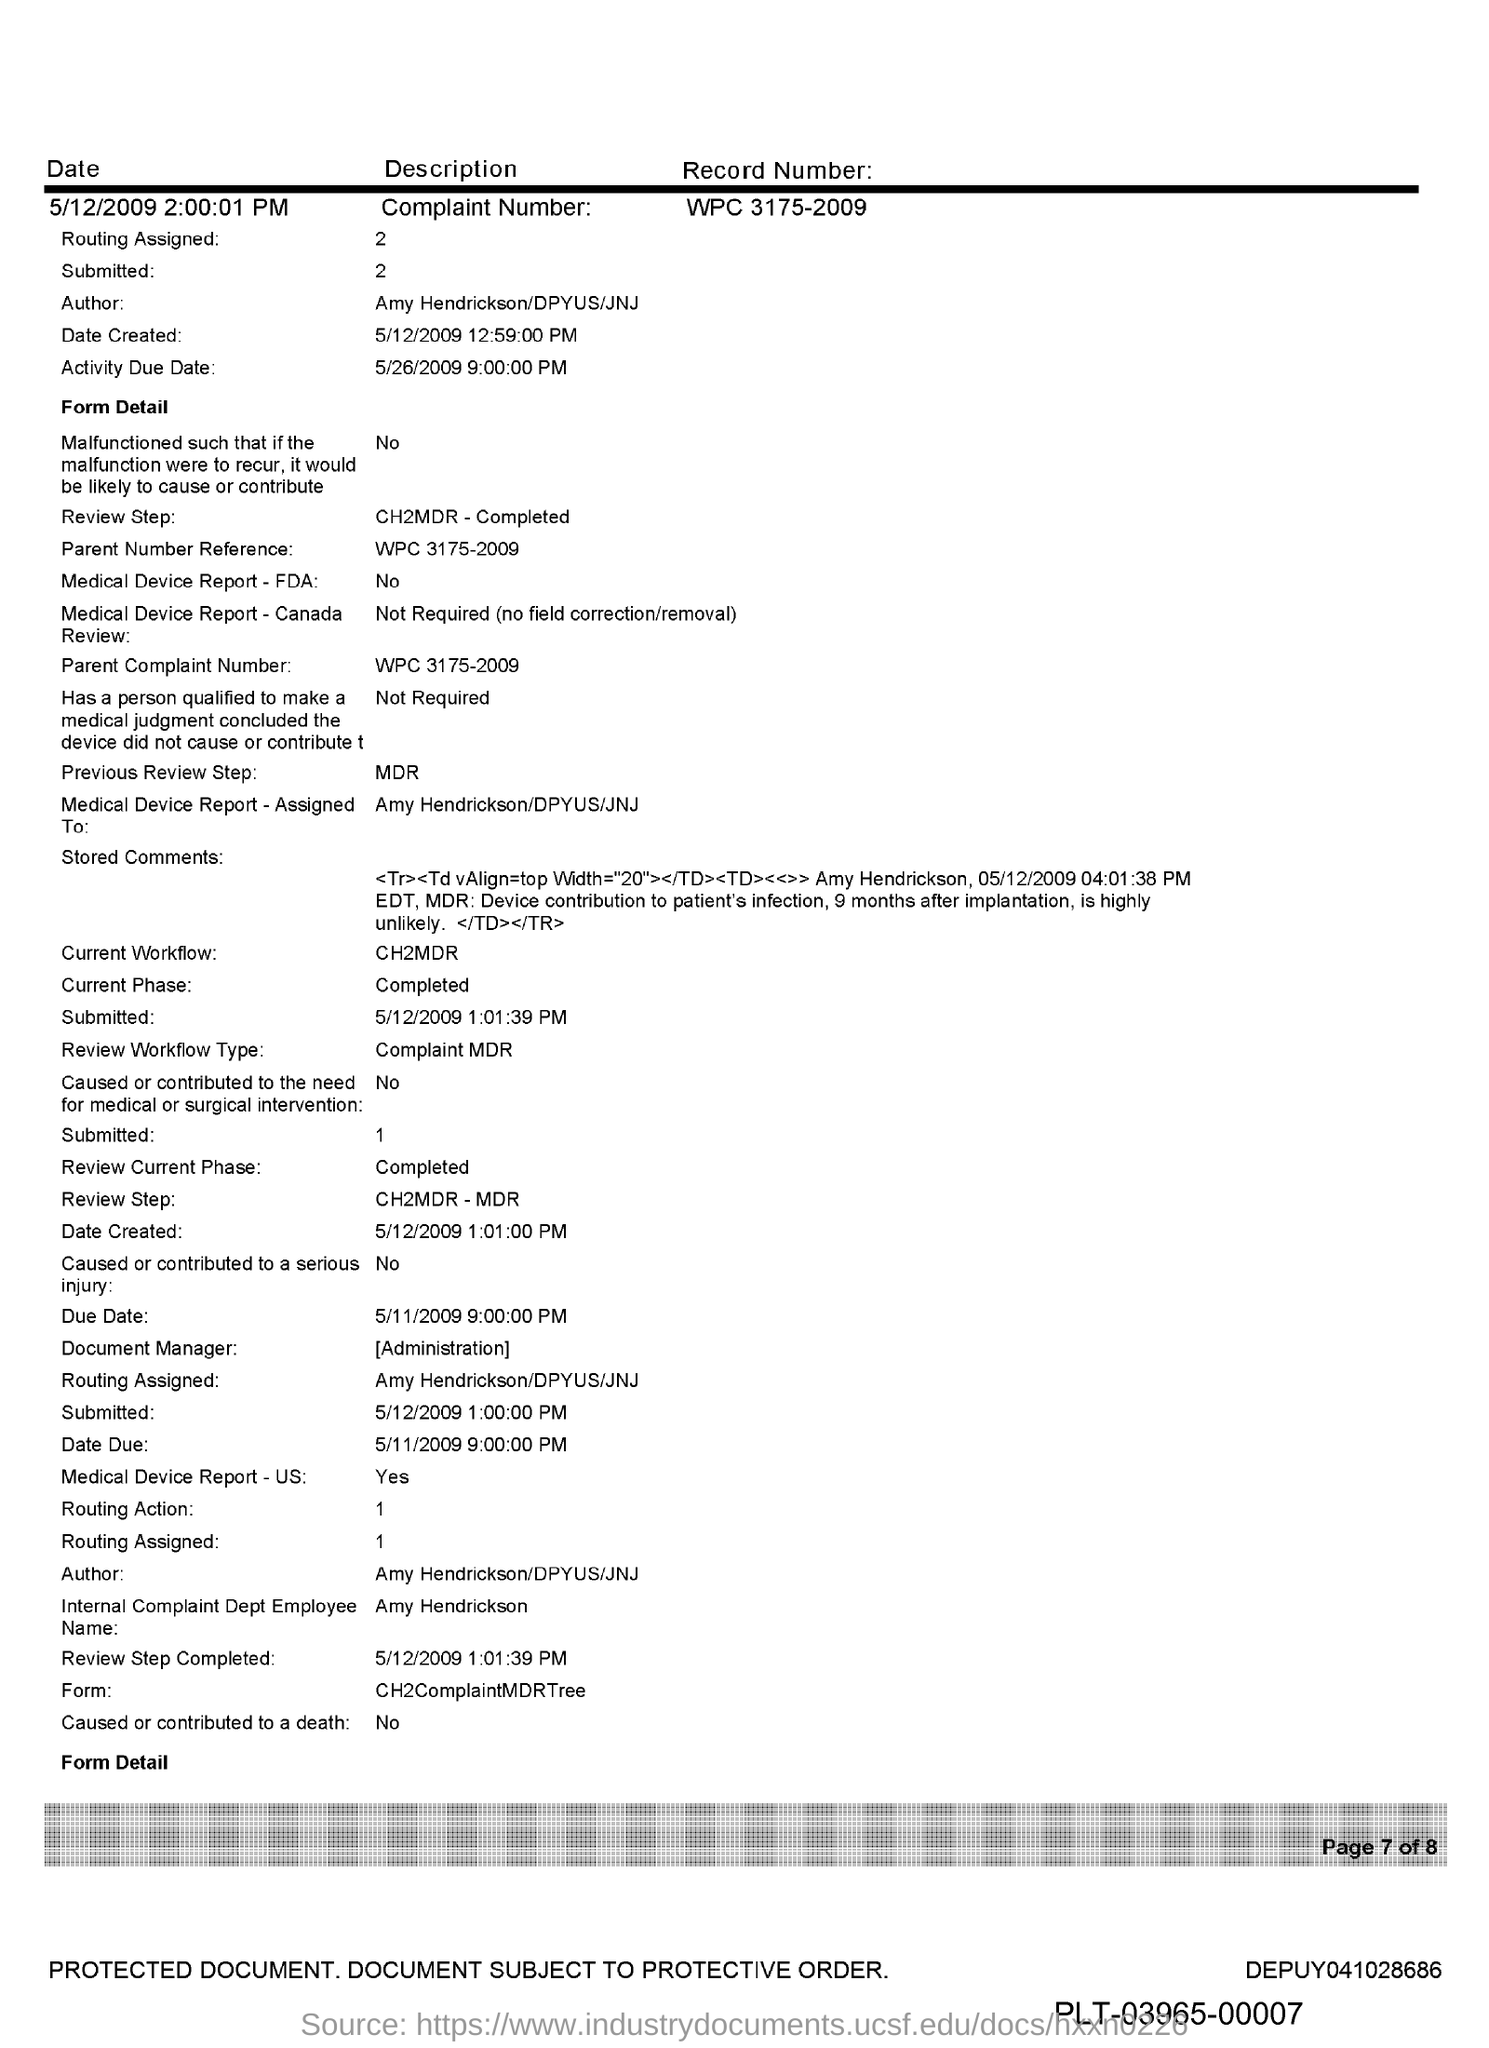Highlight a few significant elements in this photo. The Parent Reference Number is WPC 3175-2009. Amy Hendrickson, DPYUS, and JNJ are the authors of this text. 